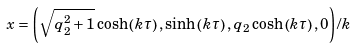Convert formula to latex. <formula><loc_0><loc_0><loc_500><loc_500>x = \left ( { \sqrt { q _ { 2 } ^ { 2 } + 1 } \cosh \left ( { k \tau } \right ) , \sinh \left ( { k \tau } \right ) , q _ { 2 } \cosh \left ( { k \tau } \right ) , 0 } \right ) / k</formula> 